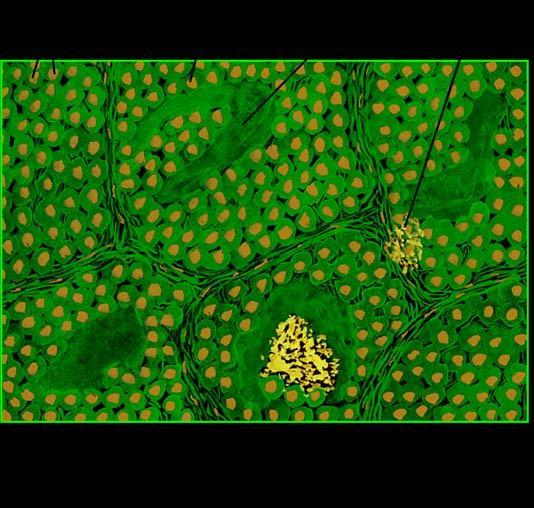does the vesselwall show congophilia which depicts apple-green birefringence under polarising microscopy?
Answer the question using a single word or phrase. No 